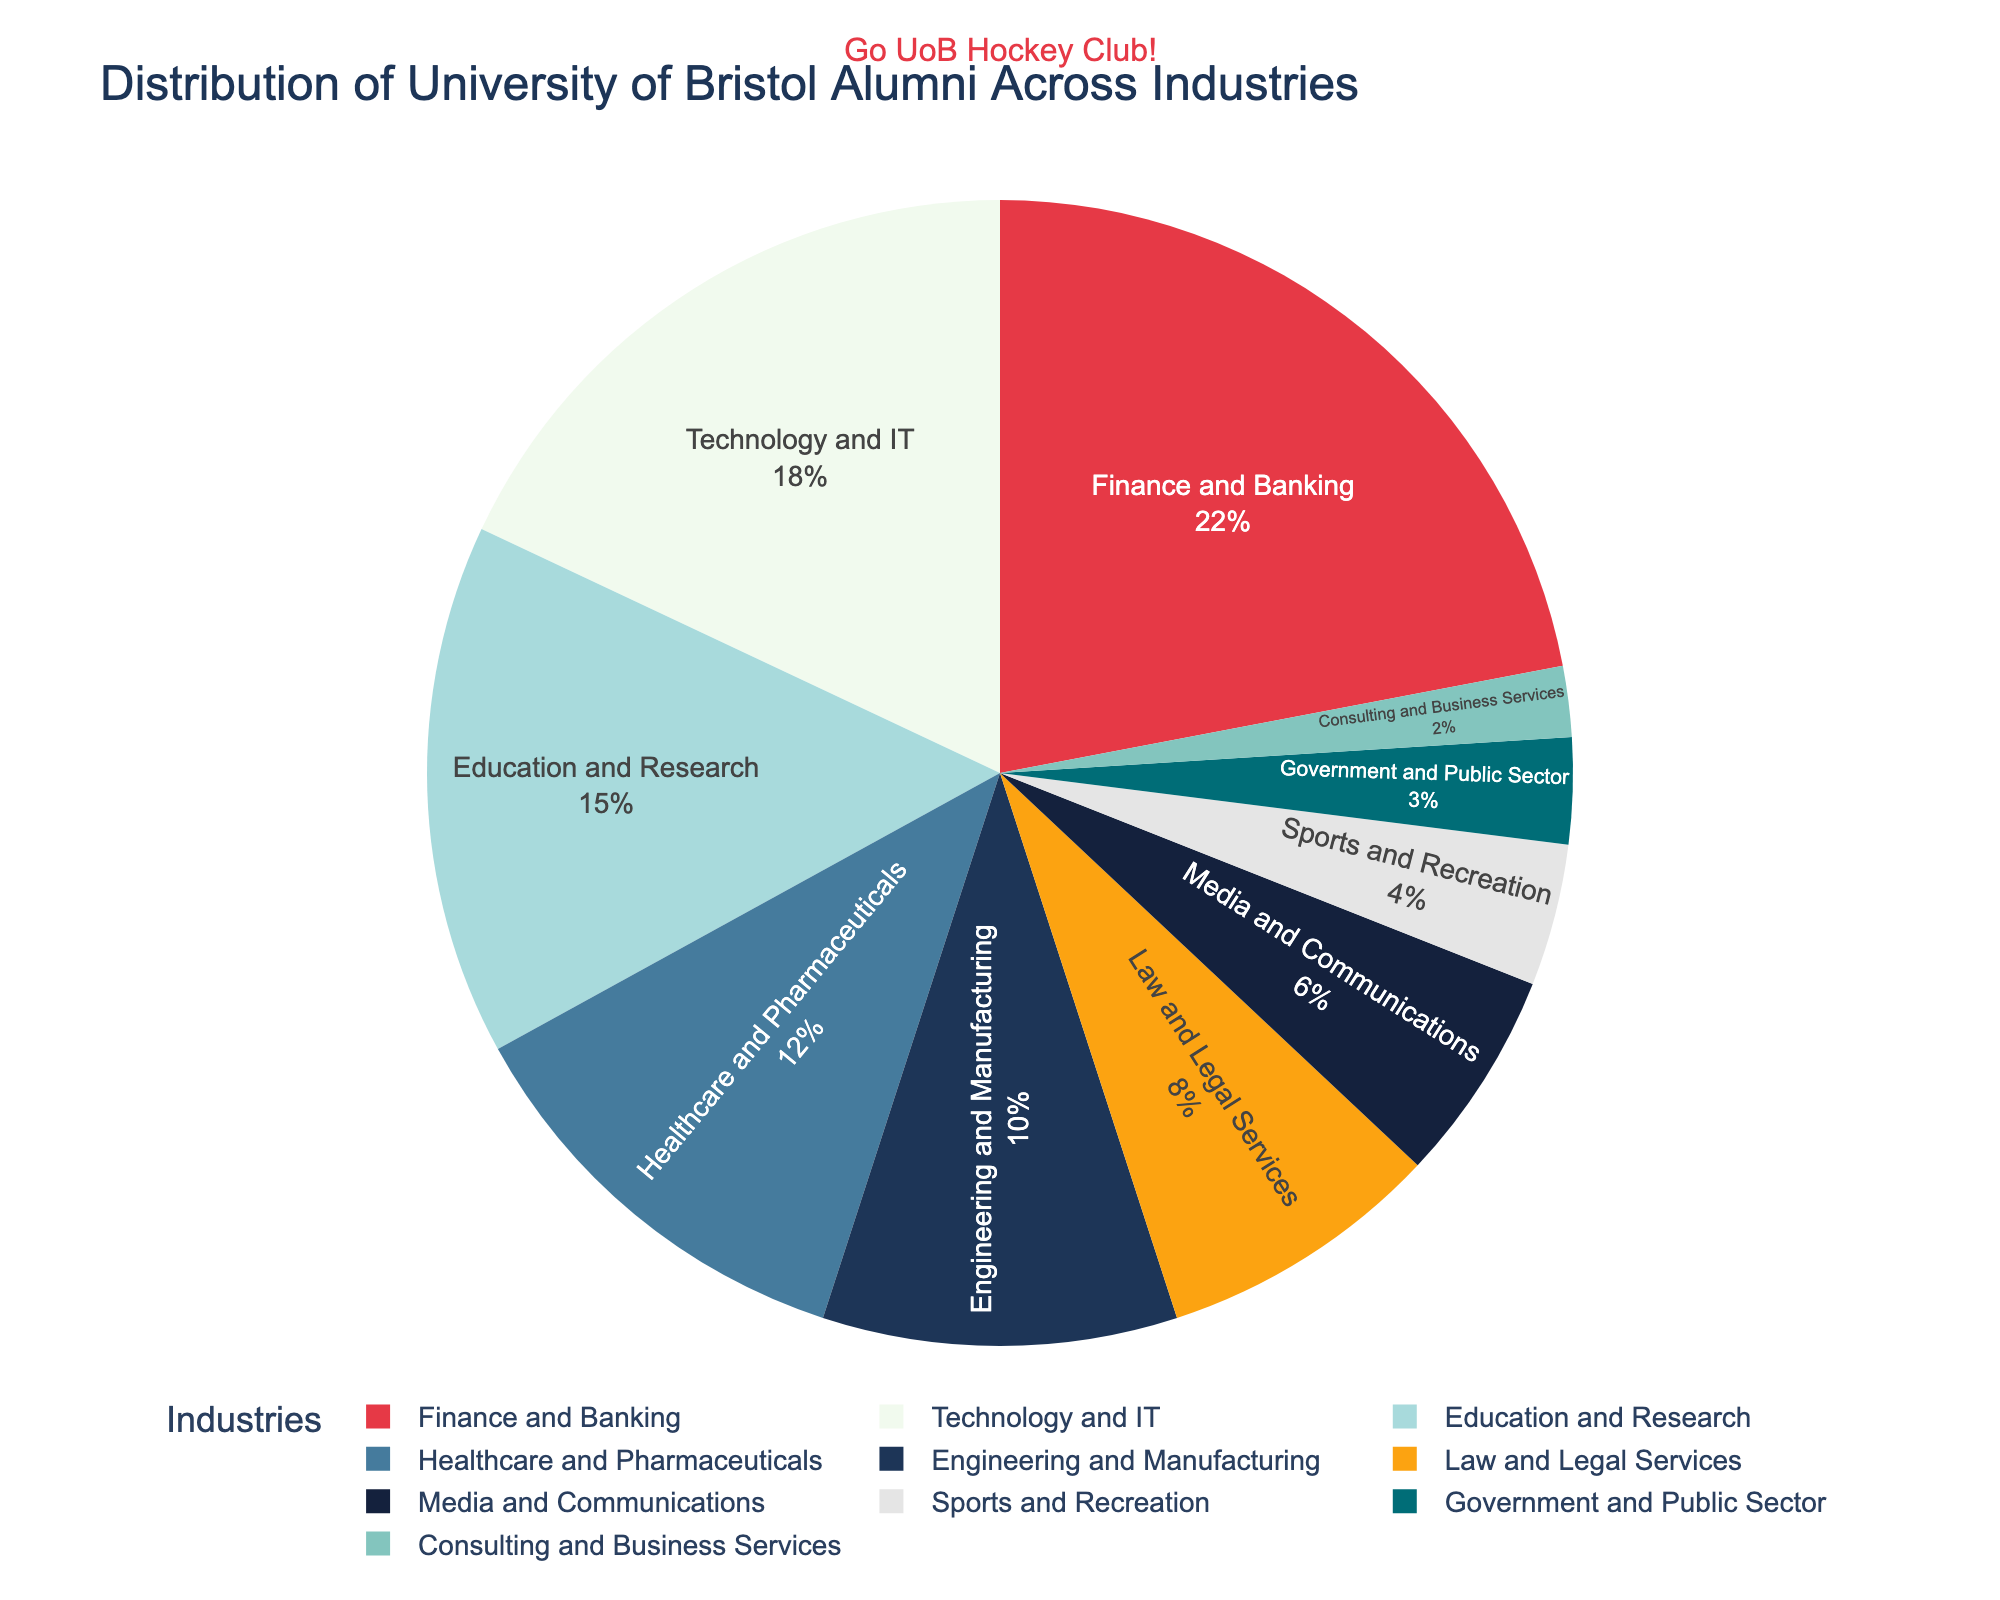What industry has the highest percentage of alumni? The pie chart shows different industries with their corresponding percentages. The section with the highest percentage is the one representing Finance and Banking at 22%.
Answer: Finance and Banking What is the combined percentage of alumni in Technology and IT and Education and Research? According to the chart, Technology and IT has 18%, and Education and Research has 15%. Adding these two values together gives us 18% + 15% = 33%.
Answer: 33% Which has a higher percentage of alumni, Healthcare and Pharmaceuticals or Engineering and Manufacturing? The chart indicates Healthcare and Pharmaceuticals at 12% and Engineering and Manufacturing at 10%. Since 12% is greater than 10%, Healthcare and Pharmaceuticals has a higher percentage.
Answer: Healthcare and Pharmaceuticals How much of a difference is there between the percentage of alumni in Law and Legal Services and Media and Communications? Law and Legal Services has 8% and Media and Communications has 6%. The difference is calculated as 8% - 6% = 2%.
Answer: 2% What fraction of the total alumni is represented by Sports and Recreation? Sports and Recreation represents 4% of the total. As a fraction, this is 4/100 which simplifies to 1/25.
Answer: 1/25 Which industry section is shown in a dark blue color? By observing the color-coded sections of the pie chart, the dark blue color represents the Engineering and Manufacturing industry.
Answer: Engineering and Manufacturing Rank the top three industries with the highest percentages of alumni. The chart shows the percentages clearly. The top three are: 1) Finance and Banking at 22%, 2) Technology and IT at 18%, and 3) Education and Research at 15%.
Answer: Finance and Banking, Technology and IT, Education and Research Is the percentage of alumni in Government and Public Sector more than in Consulting and Business Services? Government and Public Sector has 3%, while Consulting and Business Services has 2%. Since 3% is greater than 2%, the percentage in Government and Public Sector is higher.
Answer: Yes What is the total percentage of alumni in industries related to Technology, Education, and Healthcare? Adding the percentages for Technology and IT (18%), Education and Research (15%), and Healthcare and Pharmaceuticals (12%) gives 18% + 15% + 12% = 45%.
Answer: 45% 